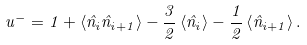Convert formula to latex. <formula><loc_0><loc_0><loc_500><loc_500>u ^ { - } = 1 + \left < \hat { n } _ { i } \hat { n } _ { i + 1 } \right > - \frac { 3 } { 2 } \left < \hat { n } _ { i } \right > - \frac { 1 } { 2 } \left < \hat { n } _ { i + 1 } \right > .</formula> 